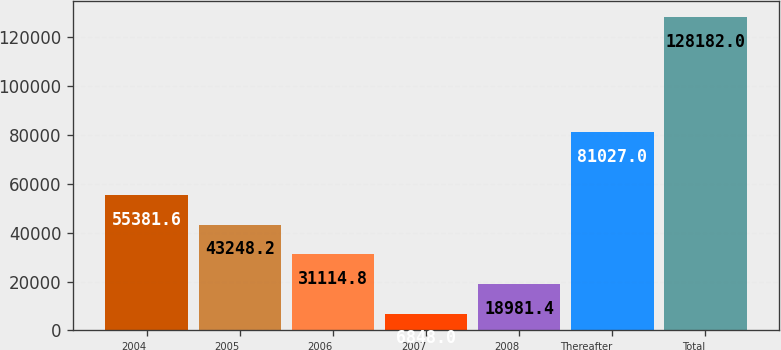<chart> <loc_0><loc_0><loc_500><loc_500><bar_chart><fcel>2004<fcel>2005<fcel>2006<fcel>2007<fcel>2008<fcel>Thereafter<fcel>Total<nl><fcel>55381.6<fcel>43248.2<fcel>31114.8<fcel>6848<fcel>18981.4<fcel>81027<fcel>128182<nl></chart> 